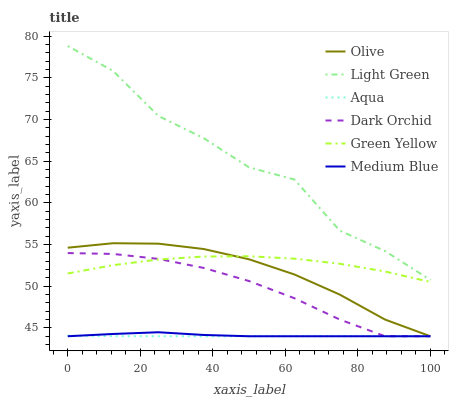Does Aqua have the minimum area under the curve?
Answer yes or no. Yes. Does Light Green have the maximum area under the curve?
Answer yes or no. Yes. Does Medium Blue have the minimum area under the curve?
Answer yes or no. No. Does Medium Blue have the maximum area under the curve?
Answer yes or no. No. Is Aqua the smoothest?
Answer yes or no. Yes. Is Light Green the roughest?
Answer yes or no. Yes. Is Medium Blue the smoothest?
Answer yes or no. No. Is Medium Blue the roughest?
Answer yes or no. No. Does Light Green have the lowest value?
Answer yes or no. No. Does Light Green have the highest value?
Answer yes or no. Yes. Does Medium Blue have the highest value?
Answer yes or no. No. Is Dark Orchid less than Light Green?
Answer yes or no. Yes. Is Green Yellow greater than Aqua?
Answer yes or no. Yes. Does Dark Orchid intersect Olive?
Answer yes or no. Yes. Is Dark Orchid less than Olive?
Answer yes or no. No. Is Dark Orchid greater than Olive?
Answer yes or no. No. Does Dark Orchid intersect Light Green?
Answer yes or no. No. 